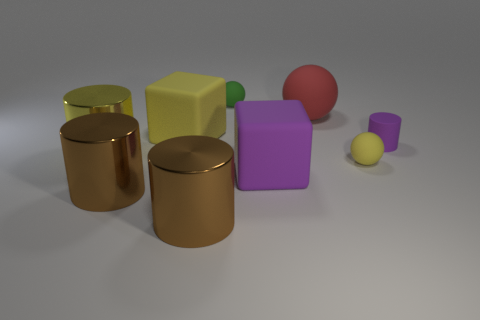Subtract all tiny green balls. How many balls are left? 2 Subtract all cylinders. How many objects are left? 5 Subtract all red balls. How many balls are left? 2 Subtract 1 blocks. How many blocks are left? 1 Subtract all gray cylinders. How many yellow spheres are left? 1 Subtract all tiny green rubber balls. Subtract all tiny blue rubber blocks. How many objects are left? 8 Add 3 yellow metal objects. How many yellow metal objects are left? 4 Add 1 large rubber spheres. How many large rubber spheres exist? 2 Subtract 2 brown cylinders. How many objects are left? 7 Subtract all brown cylinders. Subtract all gray blocks. How many cylinders are left? 2 